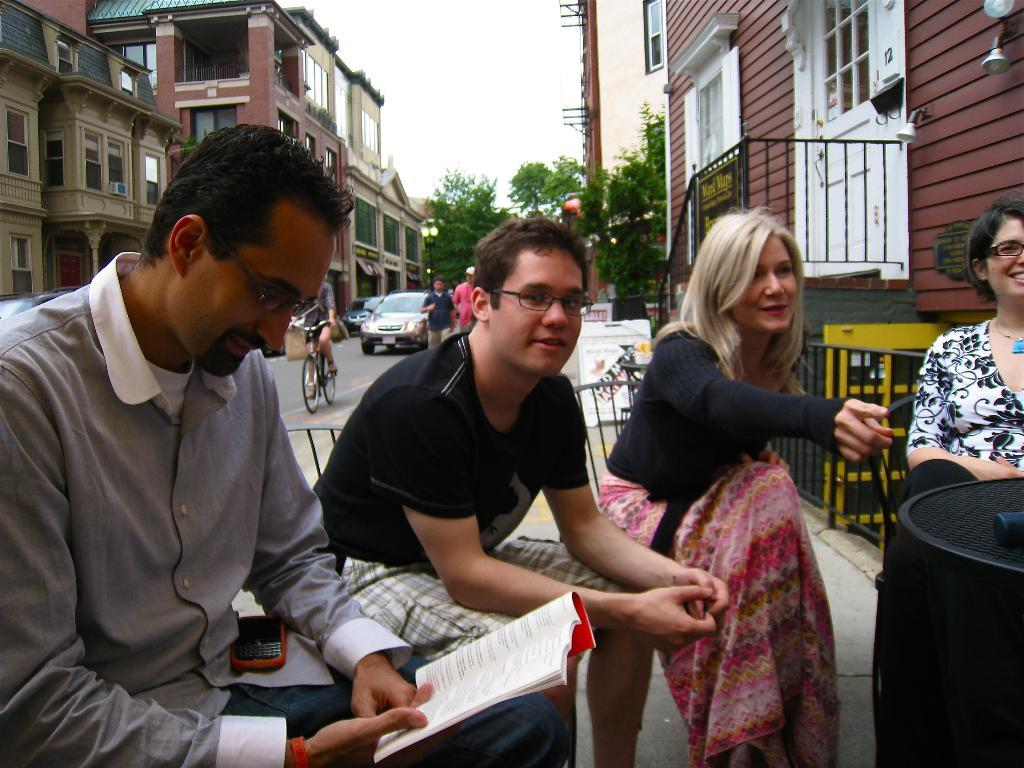What can be seen on the roadside in the image? There are vehicles on the roadside in the image. What are the people in the image doing? The people in the image are sitting on chairs. What type of structures can be seen in the image? There are buildings visible in the image. What type of vegetation is present in the image? There are trees present in the image. How many ants can be seen carrying the idea in the image? There are no ants or ideas present in the image. What type of death is depicted in the image? There is no depiction of death in the image. 